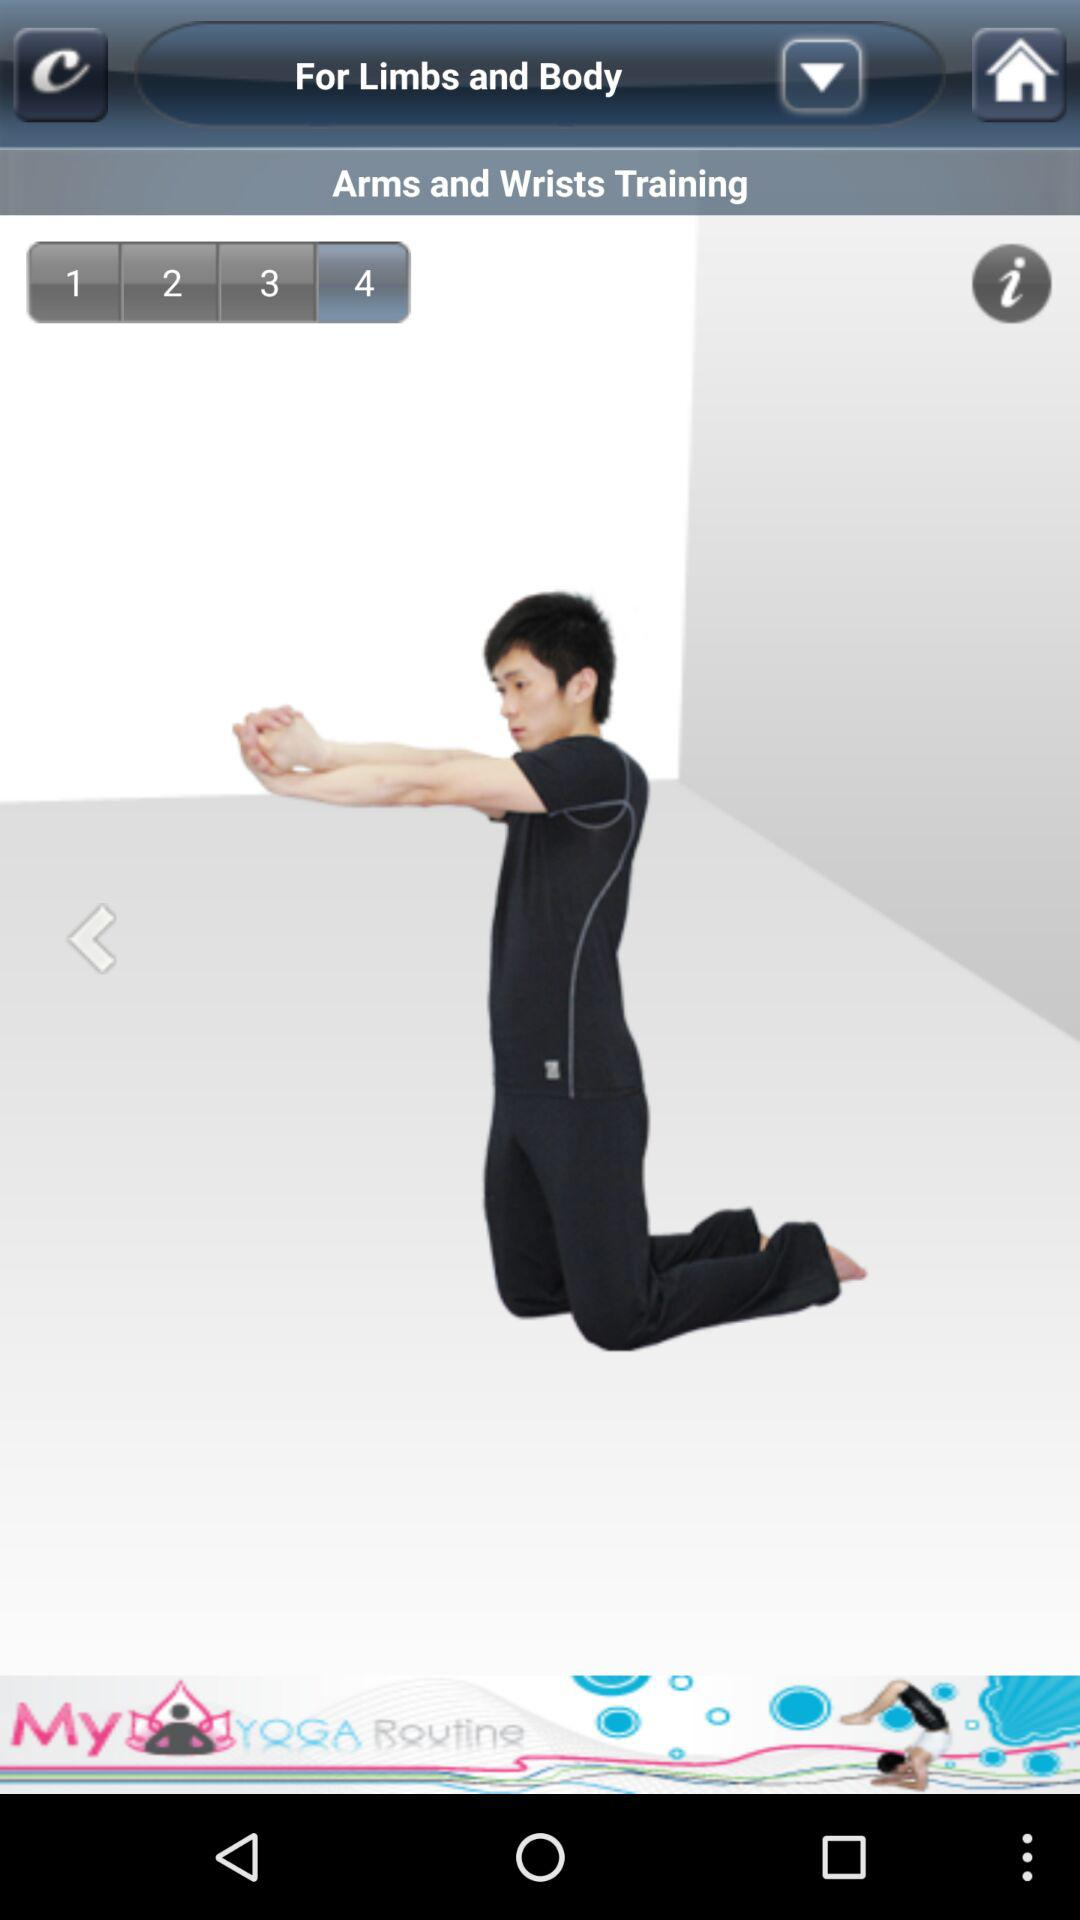Which step am I on? You are on step 4. 